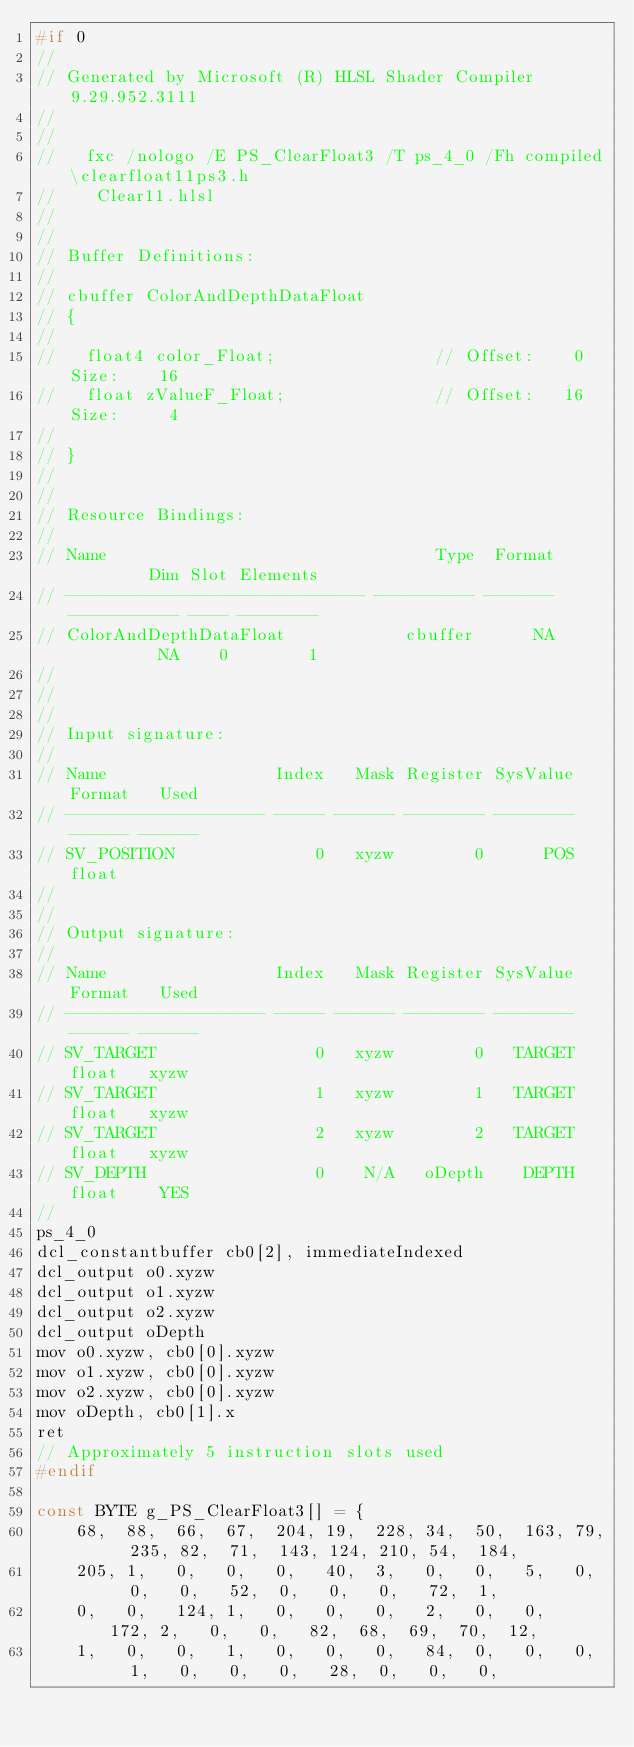<code> <loc_0><loc_0><loc_500><loc_500><_C_>#if 0
//
// Generated by Microsoft (R) HLSL Shader Compiler 9.29.952.3111
//
//
//   fxc /nologo /E PS_ClearFloat3 /T ps_4_0 /Fh compiled\clearfloat11ps3.h
//    Clear11.hlsl
//
//
// Buffer Definitions: 
//
// cbuffer ColorAndDepthDataFloat
// {
//
//   float4 color_Float;                // Offset:    0 Size:    16
//   float zValueF_Float;               // Offset:   16 Size:     4
//
// }
//
//
// Resource Bindings:
//
// Name                                 Type  Format         Dim Slot Elements
// ------------------------------ ---------- ------- ----------- ---- --------
// ColorAndDepthDataFloat            cbuffer      NA          NA    0        1
//
//
//
// Input signature:
//
// Name                 Index   Mask Register SysValue Format   Used
// -------------------- ----- ------ -------- -------- ------ ------
// SV_POSITION              0   xyzw        0      POS  float       
//
//
// Output signature:
//
// Name                 Index   Mask Register SysValue Format   Used
// -------------------- ----- ------ -------- -------- ------ ------
// SV_TARGET                0   xyzw        0   TARGET  float   xyzw
// SV_TARGET                1   xyzw        1   TARGET  float   xyzw
// SV_TARGET                2   xyzw        2   TARGET  float   xyzw
// SV_DEPTH                 0    N/A   oDepth    DEPTH  float    YES
//
ps_4_0
dcl_constantbuffer cb0[2], immediateIndexed
dcl_output o0.xyzw
dcl_output o1.xyzw
dcl_output o2.xyzw
dcl_output oDepth
mov o0.xyzw, cb0[0].xyzw
mov o1.xyzw, cb0[0].xyzw
mov o2.xyzw, cb0[0].xyzw
mov oDepth, cb0[1].x
ret 
// Approximately 5 instruction slots used
#endif

const BYTE g_PS_ClearFloat3[] = {
    68,  88,  66,  67,  204, 19,  228, 34,  50,  163, 79,  235, 82,  71,  143, 124, 210, 54,  184,
    205, 1,   0,   0,   0,   40,  3,   0,   0,   5,   0,   0,   0,   52,  0,   0,   0,   72,  1,
    0,   0,   124, 1,   0,   0,   0,   2,   0,   0,   172, 2,   0,   0,   82,  68,  69,  70,  12,
    1,   0,   0,   1,   0,   0,   0,   84,  0,   0,   0,   1,   0,   0,   0,   28,  0,   0,   0,</code> 